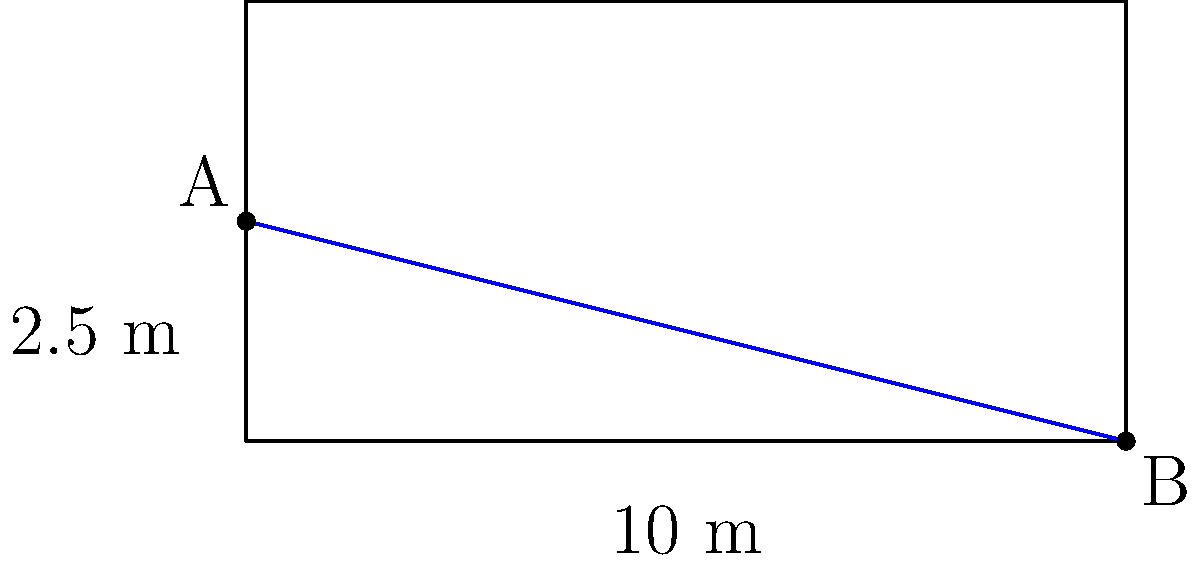You're designing a new greenhouse for your medicinal cannabis operation. The greenhouse is 10 meters long, and you want to create a slope for proper drainage. If point A is 2.5 meters high and point B is at ground level, what is the slope of the greenhouse floor as a percentage? To calculate the slope as a percentage, we need to follow these steps:

1. Calculate the rise (vertical distance):
   Rise = 2.5 m - 0 m = 2.5 m

2. Identify the run (horizontal distance):
   Run = 10 m

3. Calculate the slope using the formula:
   Slope = (Rise / Run) × 100%

4. Plug in the values:
   Slope = (2.5 m / 10 m) × 100%
         = 0.25 × 100%
         = 25%

Therefore, the slope of the greenhouse floor is 25%.
Answer: 25% 